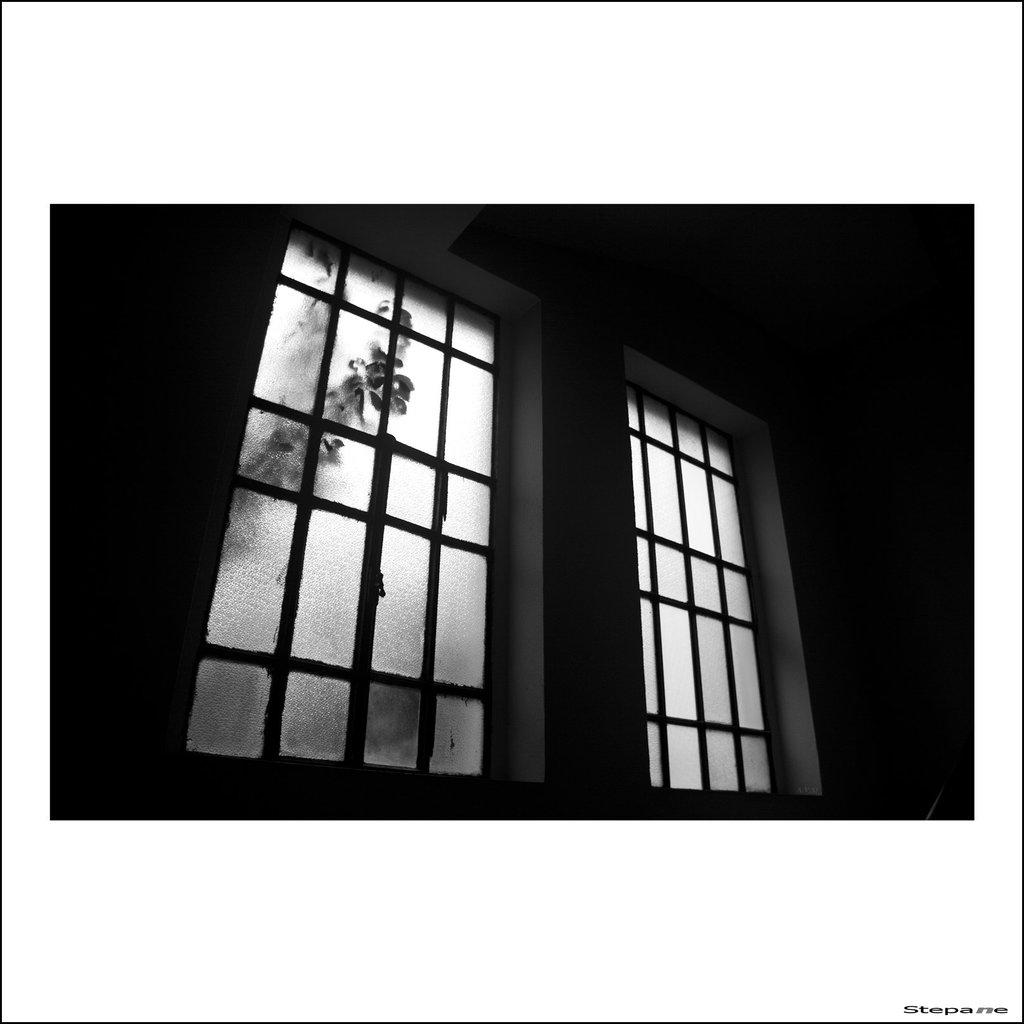What type of frame or border surrounds the image? The image has borders. What can be seen in the center of the image? There is a window in the center of the image. What is visible through the window? Plants are visible through the window. What type of architectural feature is present in the image? There is a wall in the image. How much money is being exchanged in the image? There is no exchange of money depicted in the image. What type of animals can be seen at the zoo in the image? There is no zoo or animals present in the image. 